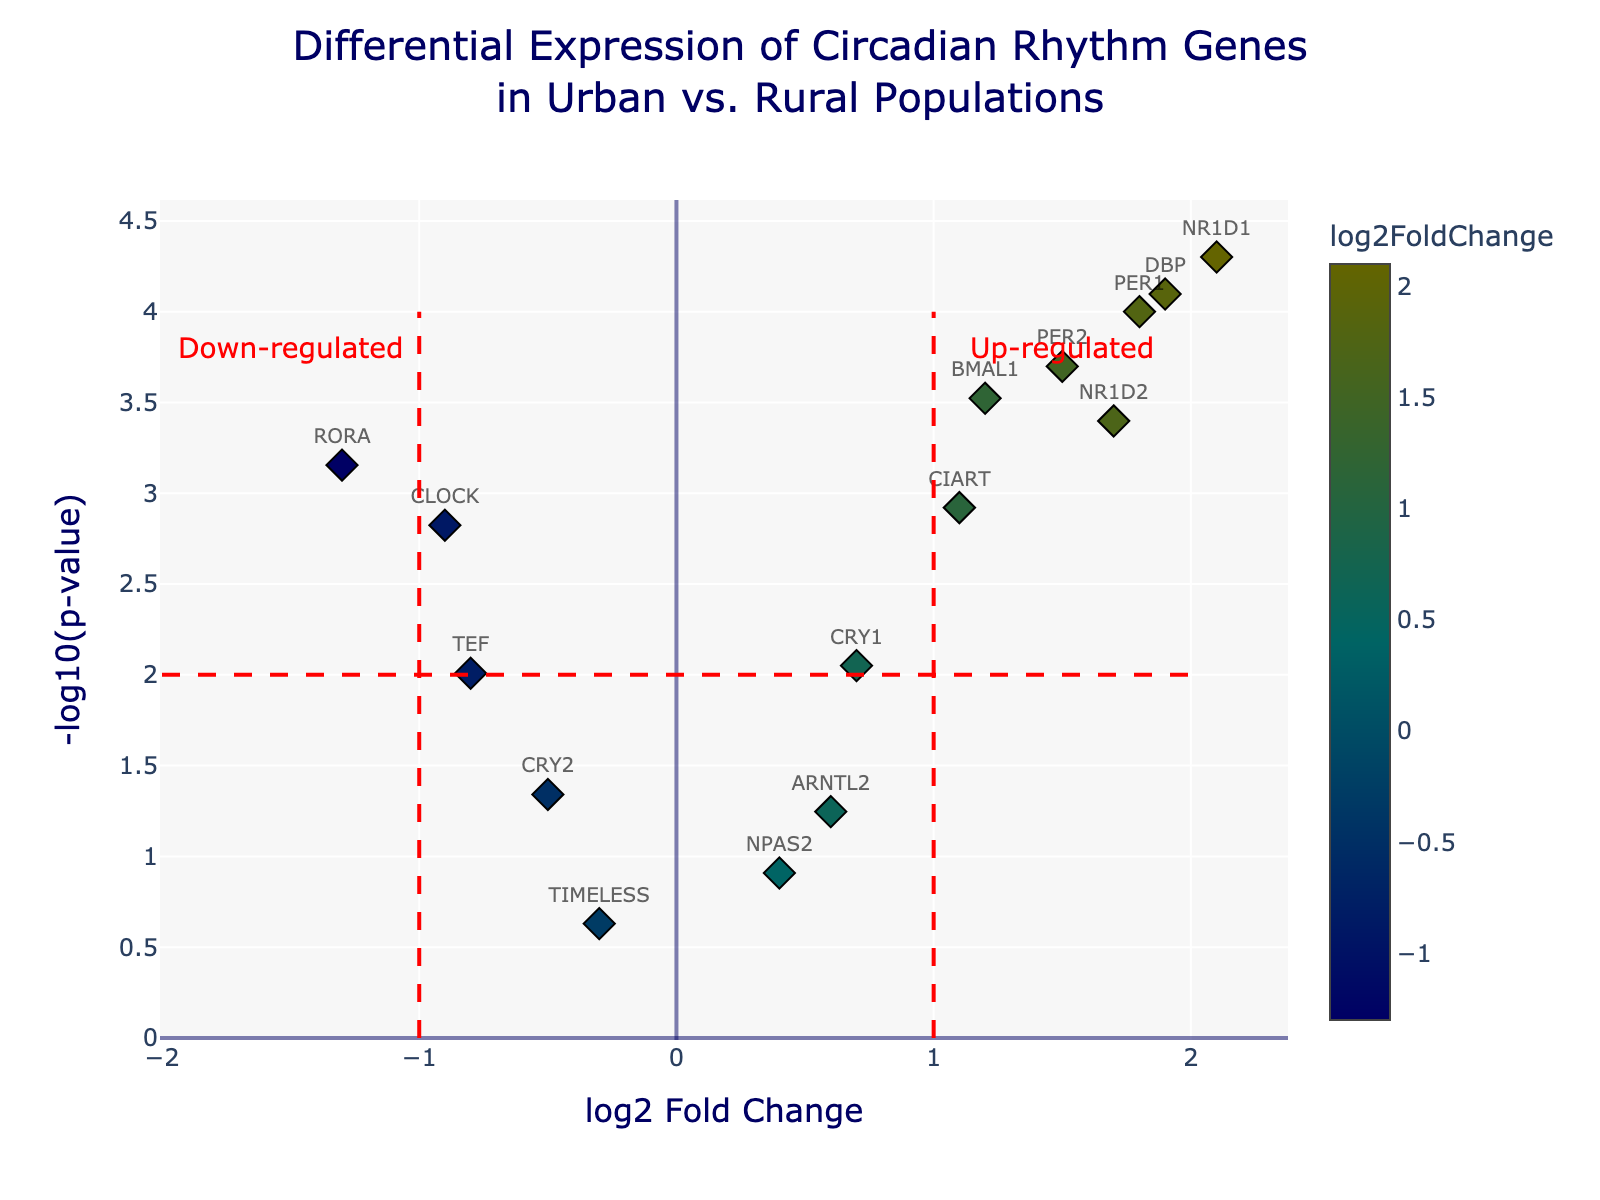What is the title of the plot? The title is displayed at the top of the plot in a larger font and a different color.
Answer: Differential Expression of Circadian Rhythm Genes in Urban vs. Rural Populations How many genes are significantly up-regulated with log2 Fold Change greater than 1? To determine this, count all data points located right of the x-axis line at 1 and above the y-axis significance threshold. Based on the plot, the number of genes fulfilling this criterion is 5.
Answer: 5 What does the x-axis represent in this plot? The x-axis shows the log2 Fold Change, which indicates the magnitude and direction (positive for up-regulation, negative for down-regulation) of gene expression differences between urban and rural populations.
Answer: log2 Fold Change Which gene has the highest log2 Fold Change, and what is its value? The gene with the highest log2 Fold Change is identified at the furthest point to the right on the x-axis. According to the data, NR1D1 has the highest log2 Fold Change of 2.1.
Answer: NR1D1, 2.1 Are there any genes with a p-value greater than 0.01, and if so, which ones? Locate the data points below the horizontal axis (y-axis) value of -log10(0.01). Based on the plot data: CRY1, TEF, CRY2, NPAS2, ARNTL2, and TIMELESS have p-values greater than 0.01.
Answer: CRY1, TEF, CRY2, NPAS2, ARNTL2, TIMELESS Which gene shows the most significant down-regulation, and what is its log2 Fold Change and p-value? The most significantly down-regulated gene will be the one furthest to the left on the x-axis and below the dashed horizontal threshold line. This is RORA, with a log2 Fold Change of -1.3 and a p-value of 0.0007.
Answer: RORA, -1.3, 0.0007 What are the x and y values (log2 Fold Change and -log10(p-value)) for BMAL1 gene? Find the data point corresponding to BMAL1 in the plot or the table. BMAL1 has a log2 Fold Change of 1.2 and a -log10(p-value) calculated as -log10(0.0003), which is approximately 3.52.
Answer: 1.2, 3.52 How many genes with -log10(p-value) greater than 3 have a negative log2 Fold Change? Identify the points above the y-axis value of 3 and to the left of the x-axis explicitly. The relevant genes are CLOCK, RORA, and TEF.
Answer: 3 What is the common attribute among genes located above the dashed red horizontal threshold? Genes above the threshold line have significant p-values (< 0.01). These represent the highest significance levels in differential expression.
Answer: Significant p-values (< 0.01) What does the y-axis threshold line marked at -log10(p-value) = 2 indicate in terms of p-values, and which genes lie above this line? The y-axis threshold line at -log10(p-value)=2 corresponds to a p-value of 0.01. The genes lying above this line have p-values smaller than 0.01, indicating higher significance. These genes are PER1, CLOCK, BMAL1, NR1D1, RORA, PER2, DBP, NR1D2, CIART.
Answer: PER1, CLOCK, BMAL1, NR1D1, RORA, PER2, DBP, NR1D2, CIART 